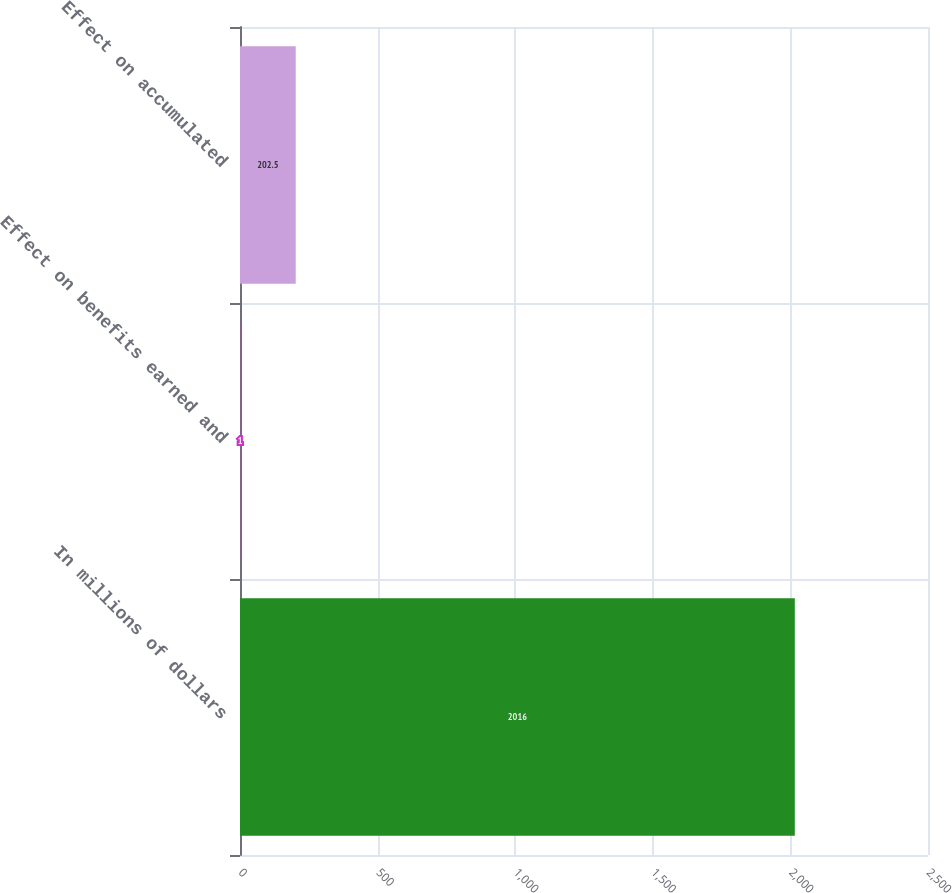Convert chart to OTSL. <chart><loc_0><loc_0><loc_500><loc_500><bar_chart><fcel>In millions of dollars<fcel>Effect on benefits earned and<fcel>Effect on accumulated<nl><fcel>2016<fcel>1<fcel>202.5<nl></chart> 